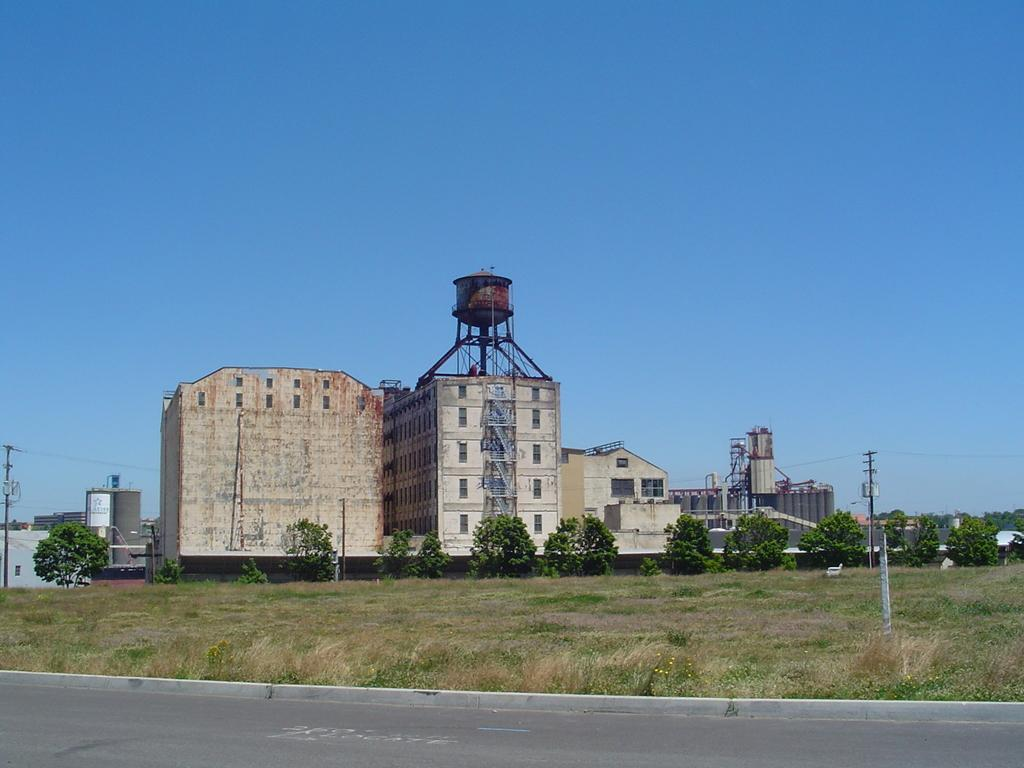What type of structures can be seen in the background of the image? There are buildings in the background of the image. What type of vegetation is at the bottom of the image? There is grass at the bottom of the image. What can be found in the middle of the image? There are trees and poles in the middle of the image. What is visible at the top of the image? The sky is visible at the top of the image. Is there a flame visible in the image? No, there is no flame present in the image. What type of alarm can be heard in the image? There is no sound or alarm present in the image; it is a still image. 